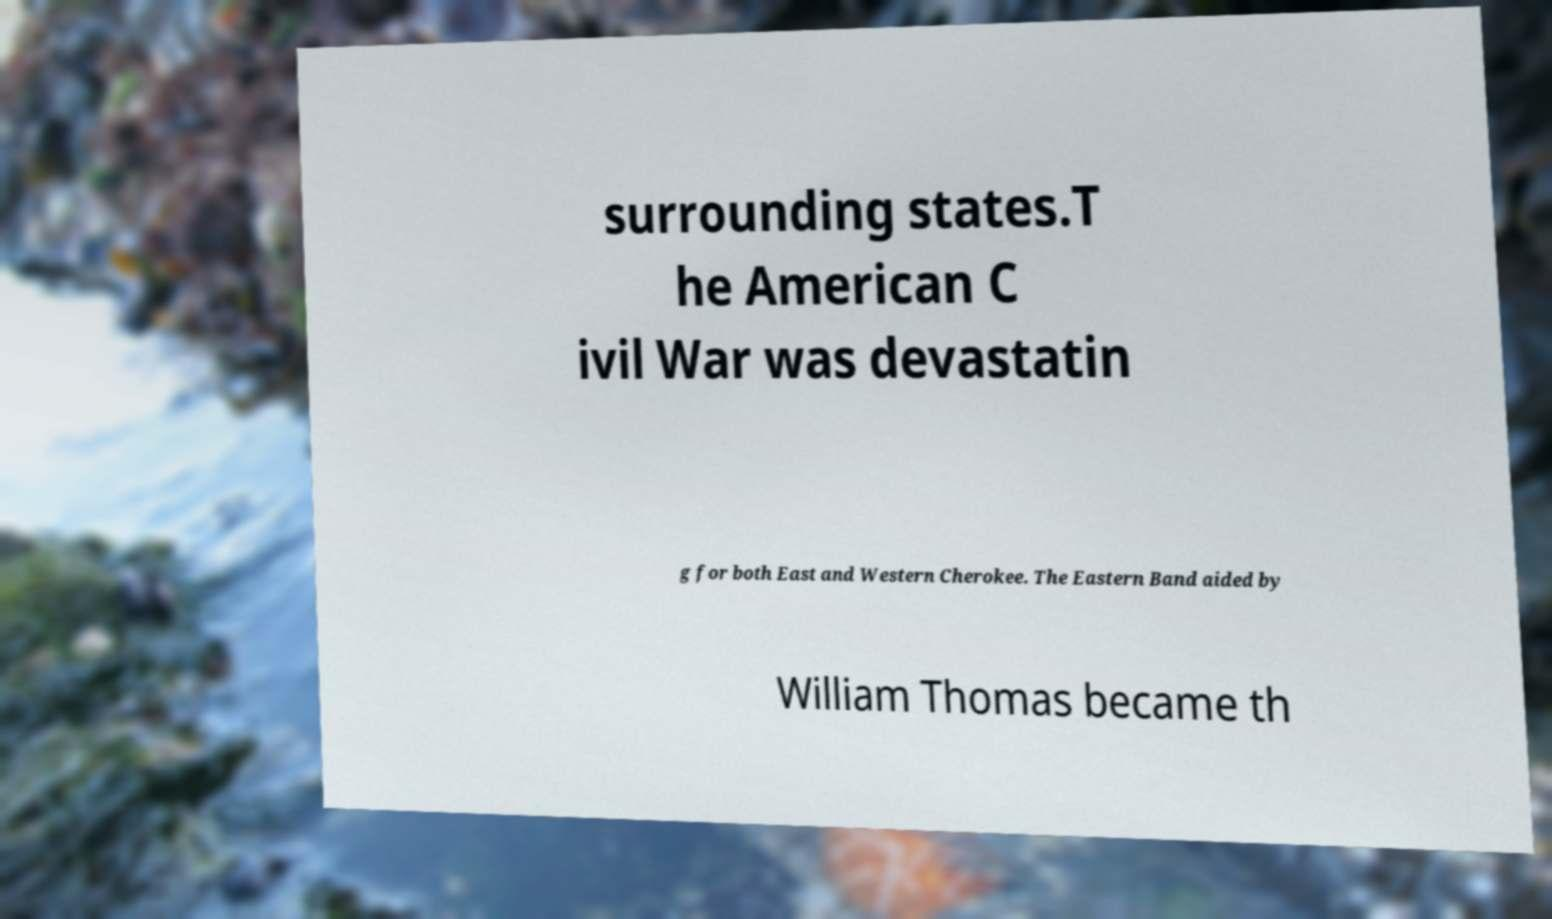Please read and relay the text visible in this image. What does it say? surrounding states.T he American C ivil War was devastatin g for both East and Western Cherokee. The Eastern Band aided by William Thomas became th 